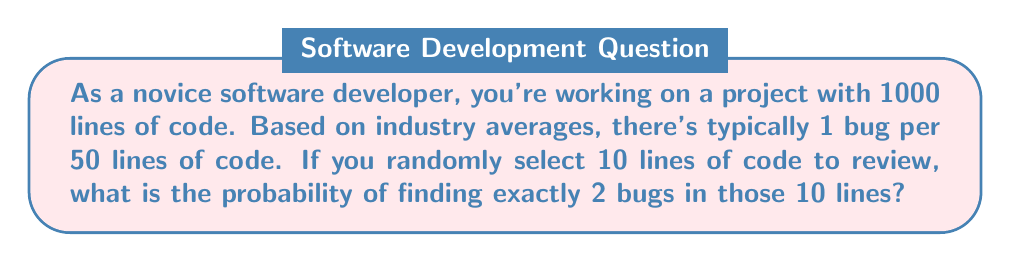Help me with this question. Let's approach this step-by-step:

1) First, we need to calculate the probability of a single line containing a bug:
   $p = \frac{1}{50} = 0.02$

2) The probability of a line not containing a bug is:
   $q = 1 - p = 0.98$

3) We're looking for exactly 2 bugs in 10 lines, which follows a binomial distribution. The probability mass function for a binomial distribution is:

   $P(X = k) = \binom{n}{k} p^k (1-p)^{n-k}$

   Where:
   $n$ = number of trials (lines of code) = 10
   $k$ = number of successes (bugs) = 2
   $p$ = probability of success on a single trial = 0.02

4) Let's calculate each part:

   $\binom{10}{2} = \frac{10!}{2!(10-2)!} = 45$

   $p^2 = 0.02^2 = 0.0004$

   $(1-p)^{10-2} = 0.98^8 \approx 0.8514$

5) Now, let's put it all together:

   $P(X = 2) = 45 \times 0.0004 \times 0.8514 \approx 0.0153$

6) Therefore, the probability of finding exactly 2 bugs in 10 randomly selected lines is approximately 0.0153 or 1.53%.
Answer: 0.0153 